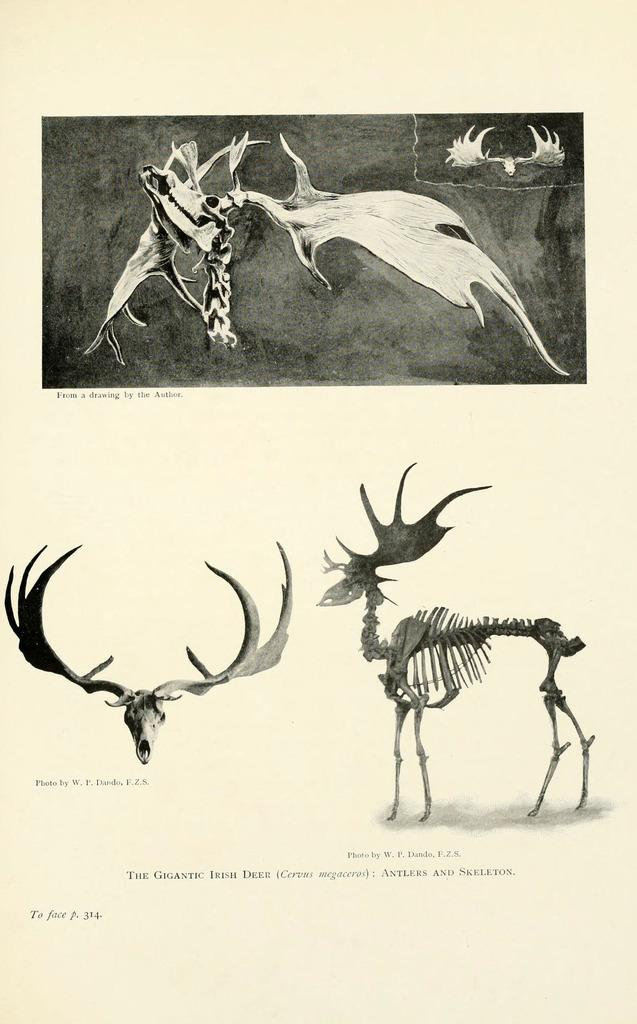What is the main subject of the paper in the image? The paper has images of animal skulls and skeletons. What else can be seen on the paper besides the images? There is text on the paper. What type of brush is used to create the images on the paper? There is no brush mentioned or visible in the image, as the images appear to be printed or drawn using other methods. 